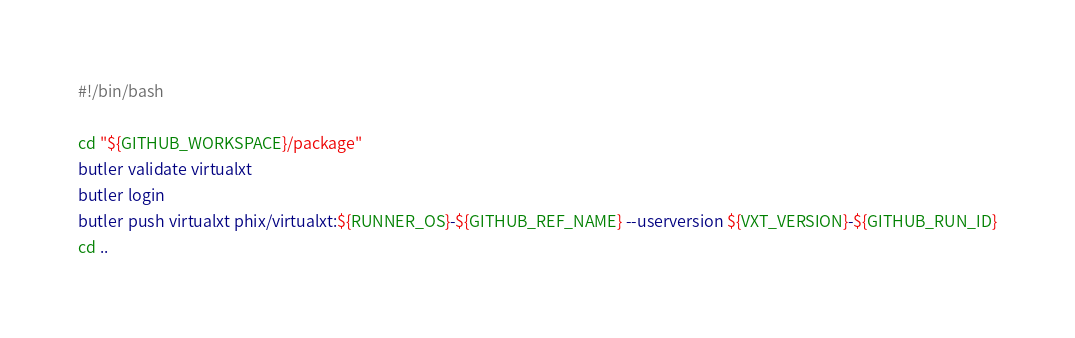<code> <loc_0><loc_0><loc_500><loc_500><_Bash_>#!/bin/bash

cd "${GITHUB_WORKSPACE}/package"
butler validate virtualxt
butler login
butler push virtualxt phix/virtualxt:${RUNNER_OS}-${GITHUB_REF_NAME} --userversion ${VXT_VERSION}-${GITHUB_RUN_ID}
cd ..</code> 